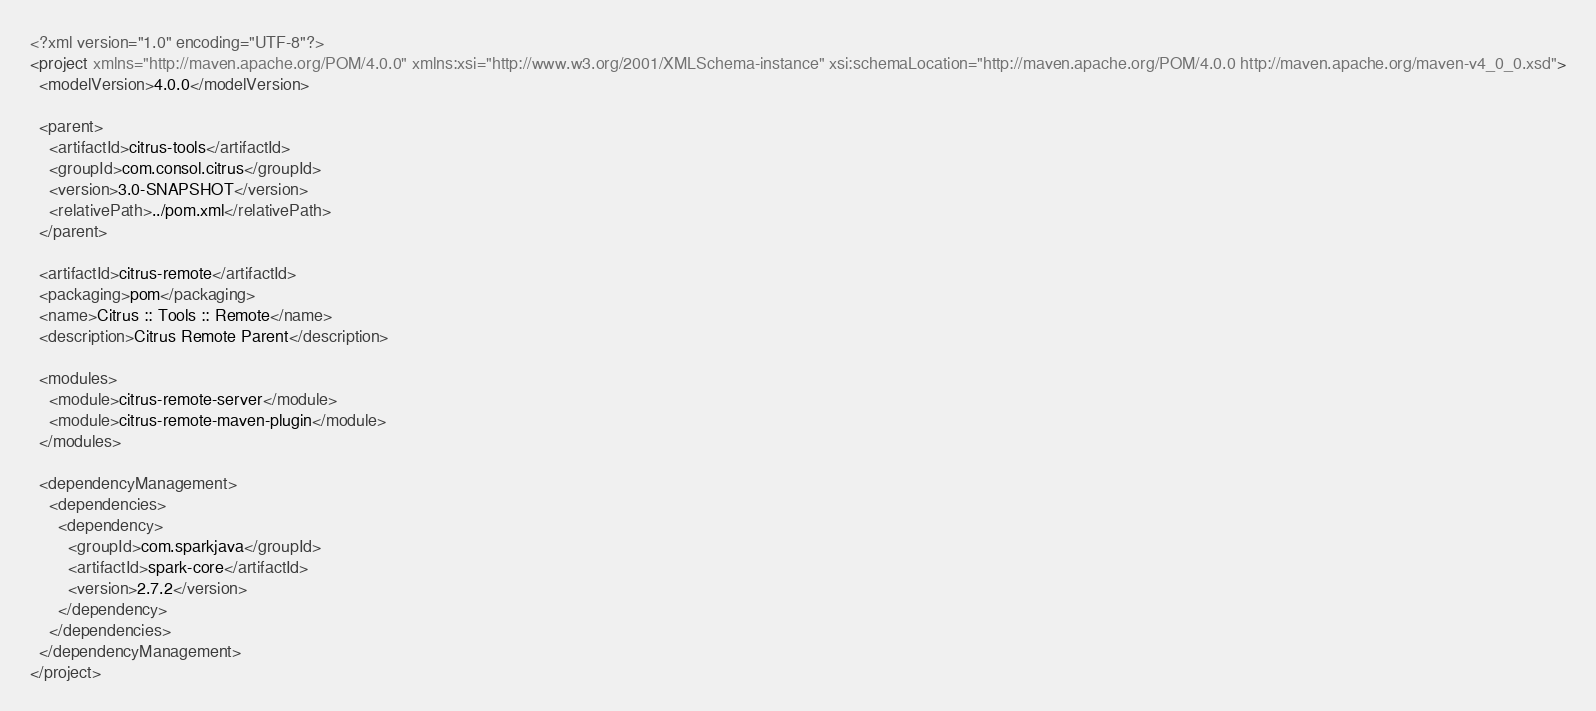Convert code to text. <code><loc_0><loc_0><loc_500><loc_500><_XML_><?xml version="1.0" encoding="UTF-8"?>
<project xmlns="http://maven.apache.org/POM/4.0.0" xmlns:xsi="http://www.w3.org/2001/XMLSchema-instance" xsi:schemaLocation="http://maven.apache.org/POM/4.0.0 http://maven.apache.org/maven-v4_0_0.xsd">
  <modelVersion>4.0.0</modelVersion>

  <parent>
    <artifactId>citrus-tools</artifactId>
    <groupId>com.consol.citrus</groupId>
    <version>3.0-SNAPSHOT</version>
    <relativePath>../pom.xml</relativePath>
  </parent>

  <artifactId>citrus-remote</artifactId>
  <packaging>pom</packaging>
  <name>Citrus :: Tools :: Remote</name>
  <description>Citrus Remote Parent</description>

  <modules>
    <module>citrus-remote-server</module>
    <module>citrus-remote-maven-plugin</module>
  </modules>

  <dependencyManagement>
    <dependencies>
      <dependency>
        <groupId>com.sparkjava</groupId>
        <artifactId>spark-core</artifactId>
        <version>2.7.2</version>
      </dependency>
    </dependencies>
  </dependencyManagement>
</project>
</code> 